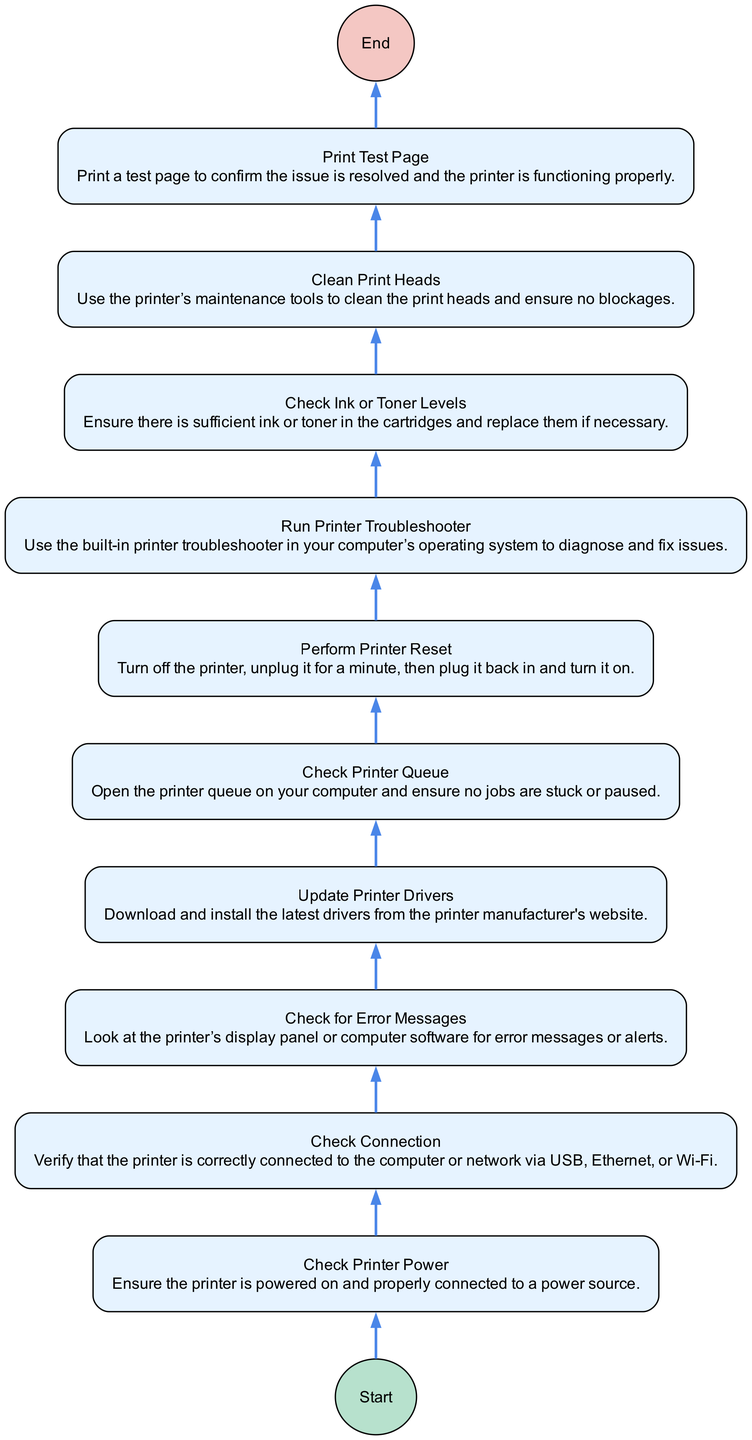What is the first step in the troubleshooting process? The diagram starts with a node labeled "Check Printer Power," indicating that it is the first action to take. This node is positioned at the bottom and connects directly to the start node.
Answer: Check Printer Power What is the last step to confirm that the printer works? The final node in the sequence is "Print Test Page." This indicates that after going through previous troubleshooting steps, printing a test page confirms if the issue has been resolved.
Answer: Print Test Page How many total steps are included in the troubleshooting flowchart? The flowchart has a total of 10 steps, which can be counted from the nodes listed in the diagram. Each unique action or check represents one step.
Answer: 10 Which step follows "Check for Error Messages"? In the flowchart, "Update Printer Drivers" is the node that directly follows "Check for Error Messages," as indicated by the arrows connecting the nodes sequentially.
Answer: Update Printer Drivers What action is performed after checking ink or toner levels? After the "Check Ink or Toner Levels" step, the next action in the flowchart is "Clean Print Heads.” This indicates that if ink or toner levels are sufficient, the focus shifts to maintaining the print heads.
Answer: Clean Print Heads Which step is recommended before running the built-in troubleshooter? The step "Check Printer Queue" is indicated before "Run Printer Troubleshooter." This means ensuring that there are no pending print jobs before diagnosing printer issues.
Answer: Check Printer Queue What should be the next action if you find an error message? The flowchart suggests that if there is an error message, the next appropriate step is "Update Printer Drivers," leading to ensuring that the software is up-to-date for optimal performance.
Answer: Update Printer Drivers How many nodes represent the checking of printer conditions? There are 5 nodes that specifically represent checking various conditions: "Check Printer Power," "Check Connection," "Check for Error Messages," "Check Ink or Toner Levels," and "Check Printer Queue."
Answer: 5 What is the purpose of combining the actions in this flowchart? The flowchart is structured to guide users through systematic troubleshooting steps, ensuring that users check, maintain, and reset their printer effectively to resolve common problems.
Answer: Troubleshooting guidance 